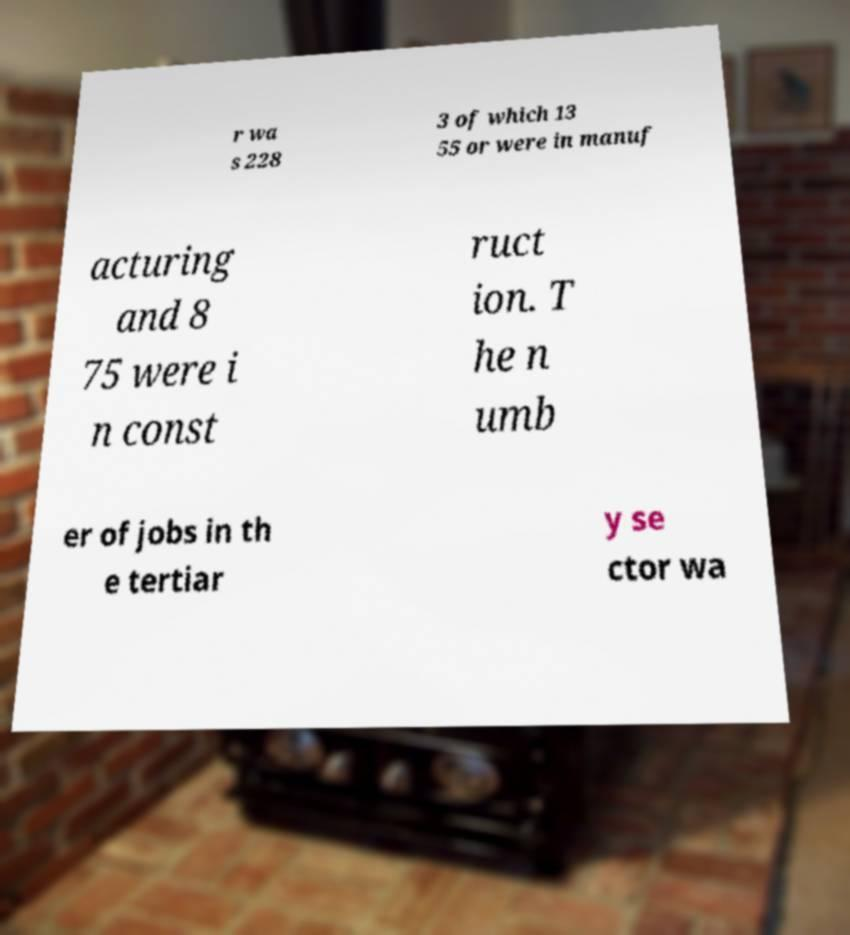Can you accurately transcribe the text from the provided image for me? r wa s 228 3 of which 13 55 or were in manuf acturing and 8 75 were i n const ruct ion. T he n umb er of jobs in th e tertiar y se ctor wa 